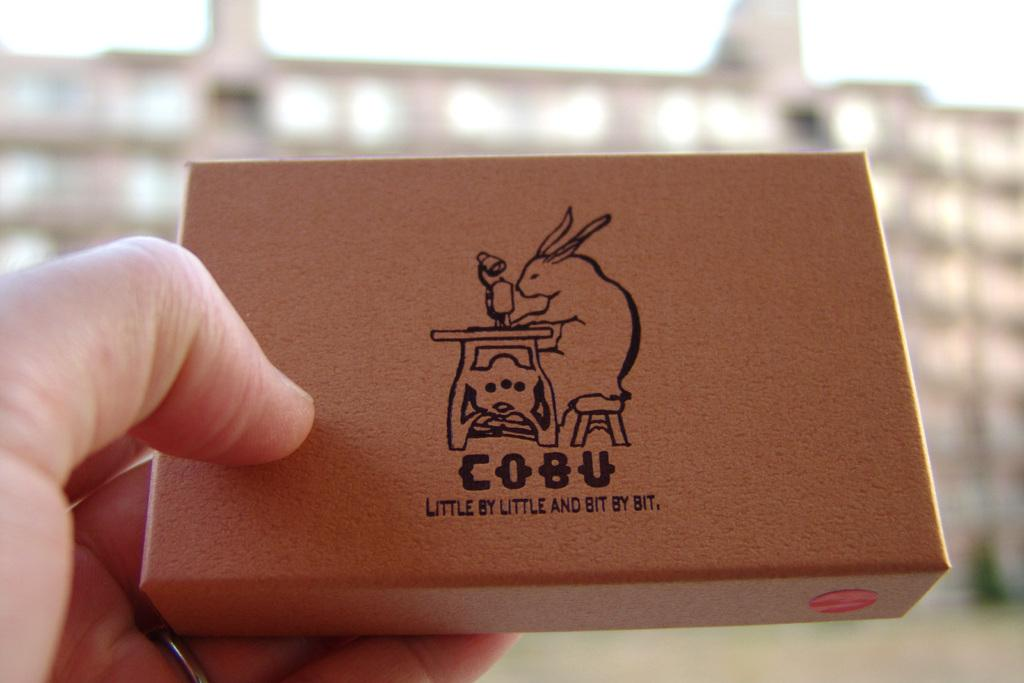<image>
Provide a brief description of the given image. Someone holding a Cobu box with a rabbit sewing. 